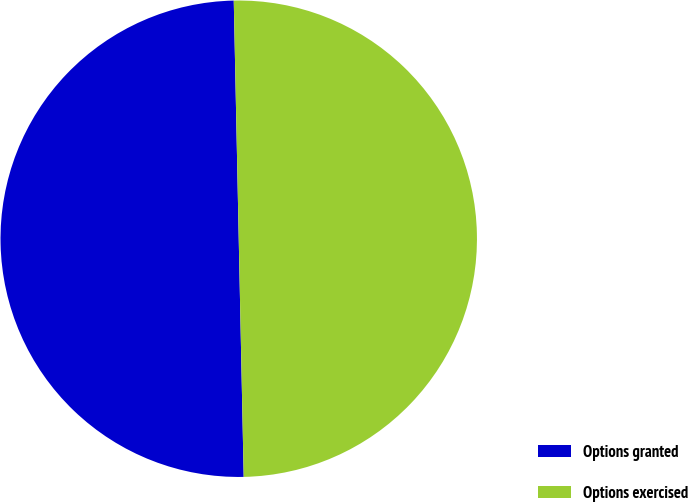Convert chart to OTSL. <chart><loc_0><loc_0><loc_500><loc_500><pie_chart><fcel>Options granted<fcel>Options exercised<nl><fcel>50.0%<fcel>50.0%<nl></chart> 